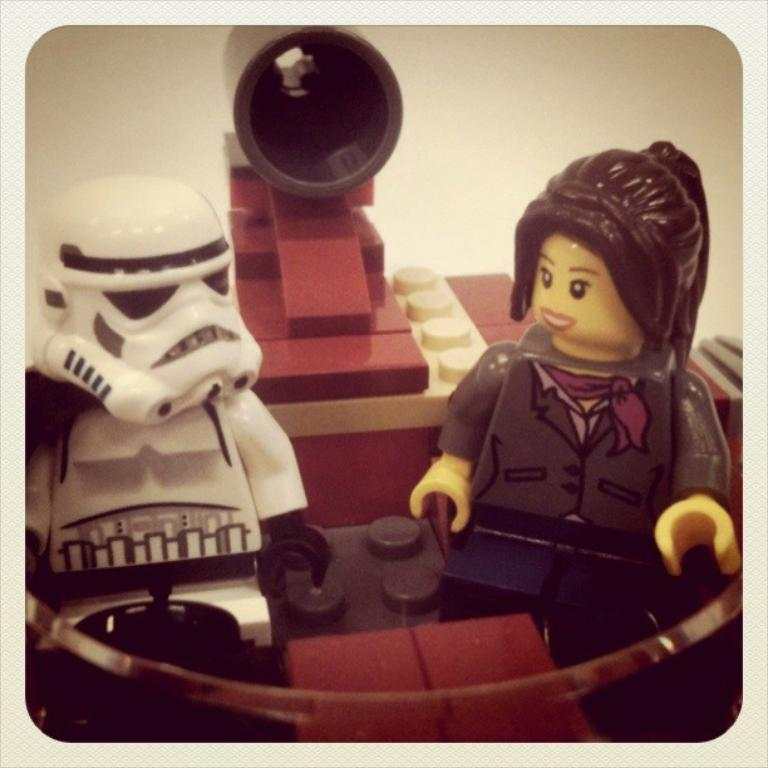What objects are present in the image? There are toys in the image. What color is the background of the image? The background of the image is white. What type of railway is visible in the image? There is no railway present in the image; it only features toys and a white background. What kind of lunch is being served in the image? There is no lunch or food visible in the image; it only features toys and a white background. 